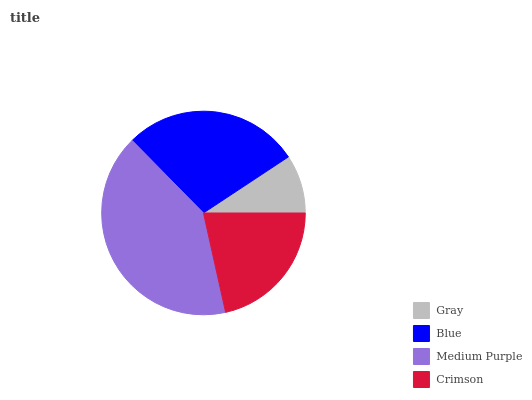Is Gray the minimum?
Answer yes or no. Yes. Is Medium Purple the maximum?
Answer yes or no. Yes. Is Blue the minimum?
Answer yes or no. No. Is Blue the maximum?
Answer yes or no. No. Is Blue greater than Gray?
Answer yes or no. Yes. Is Gray less than Blue?
Answer yes or no. Yes. Is Gray greater than Blue?
Answer yes or no. No. Is Blue less than Gray?
Answer yes or no. No. Is Blue the high median?
Answer yes or no. Yes. Is Crimson the low median?
Answer yes or no. Yes. Is Gray the high median?
Answer yes or no. No. Is Gray the low median?
Answer yes or no. No. 